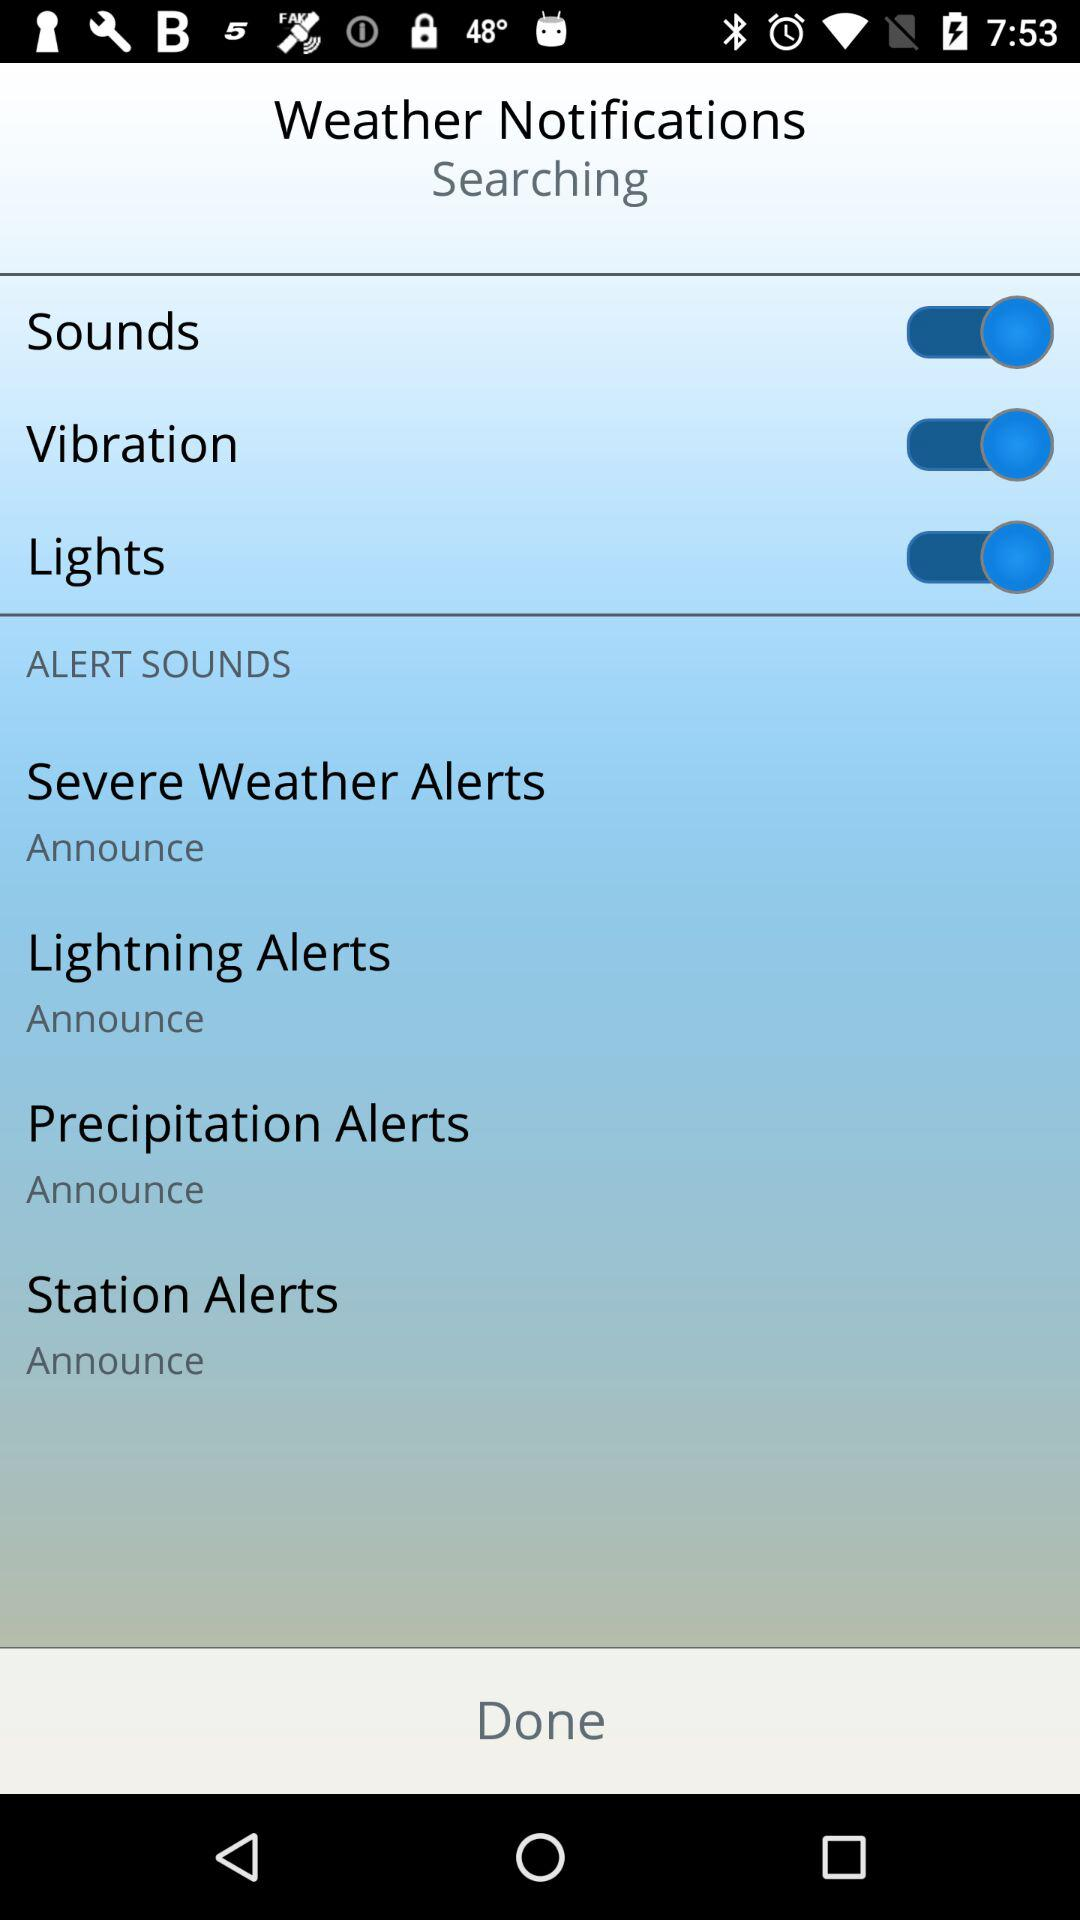Which options are enabled? The enabled options are : "Sounds", "Vibration", and "Lights". 